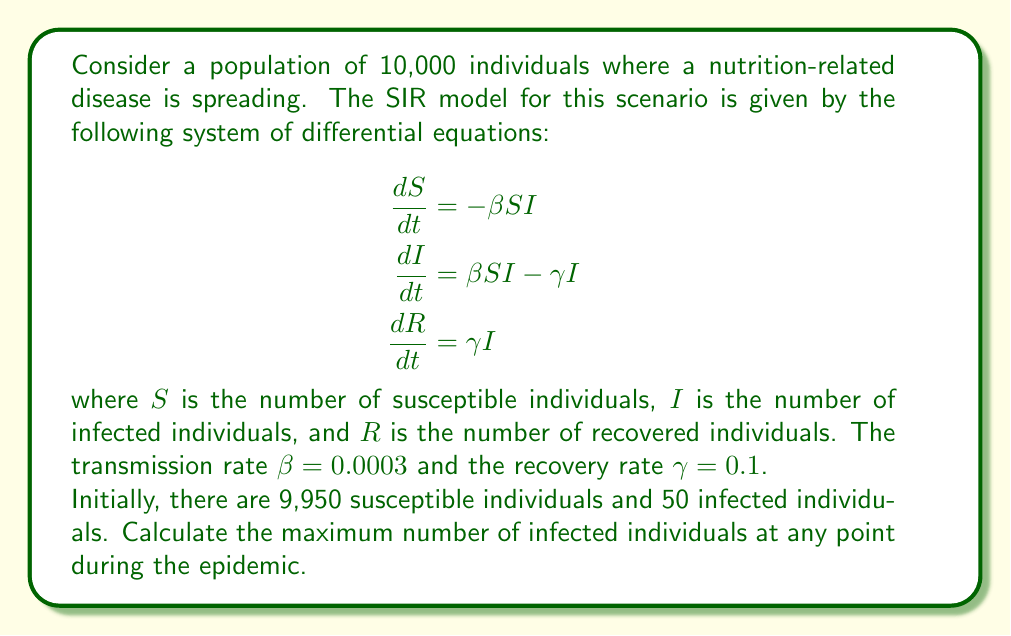Solve this math problem. To solve this problem, we need to follow these steps:

1) First, we need to find the time when the number of infected individuals reaches its peak. This occurs when $\frac{dI}{dt} = 0$.

2) From the second equation in the SIR model:

   $$\frac{dI}{dt} = \beta SI - \gamma I = 0$$

3) Solving this equation:

   $$\beta SI - \gamma I = 0$$
   $$I(\beta S - \gamma) = 0$$

   Since $I \neq 0$ at the peak, we must have:

   $$\beta S - \gamma = 0$$
   $$S = \frac{\gamma}{\beta} = \frac{0.1}{0.0003} \approx 333.33$$

4) This means that when the number of infected individuals reaches its peak, there will be approximately 333 susceptible individuals.

5) We can use the conservation of population to find the maximum number of infected individuals:

   $$N = S + I + R = 10,000$$

   At the start of the epidemic:
   $$S_0 = 9,950, I_0 = 50, R_0 = 0$$

6) At the peak of infection:
   $$S_{peak} \approx 333$$
   $$I_{peak} + R_{peak} = 10,000 - 333 = 9,667$$

7) To find $R_{peak}$, we can use the fact that the ratio of $S$ to $R$ remains constant throughout the epidemic:

   $$\frac{S}{R} = \frac{S_0}{R_0}e^{-\frac{\beta}{\gamma}(R-R_0)}$$

   $$333 = 9,950e^{-\frac{0.0003}{0.1}R_{peak}}$$

   Solving this equation numerically gives us $R_{peak} \approx 6,061$

8) Therefore, the maximum number of infected individuals is:

   $$I_{peak} = 9,667 - 6,061 = 3,606$$
Answer: The maximum number of infected individuals during the epidemic is approximately 3,606. 